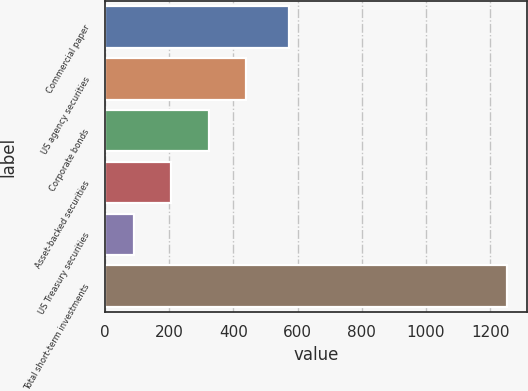Convert chart to OTSL. <chart><loc_0><loc_0><loc_500><loc_500><bar_chart><fcel>Commercial paper<fcel>US agency securities<fcel>Corporate bonds<fcel>Asset-backed securities<fcel>US Treasury securities<fcel>Total short-term investments<nl><fcel>573<fcel>439.3<fcel>323.2<fcel>207.1<fcel>91<fcel>1252<nl></chart> 